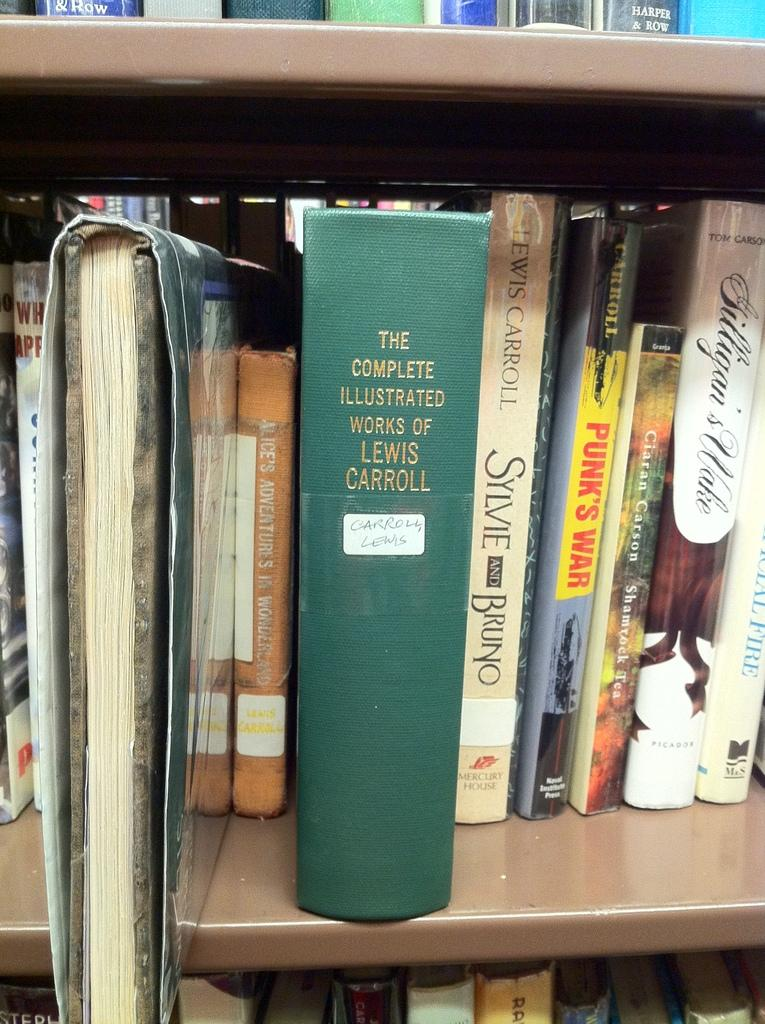<image>
Render a clear and concise summary of the photo. The bookshelf contains a thick green book containing the complete illustrated works of Lewis Carroll. 